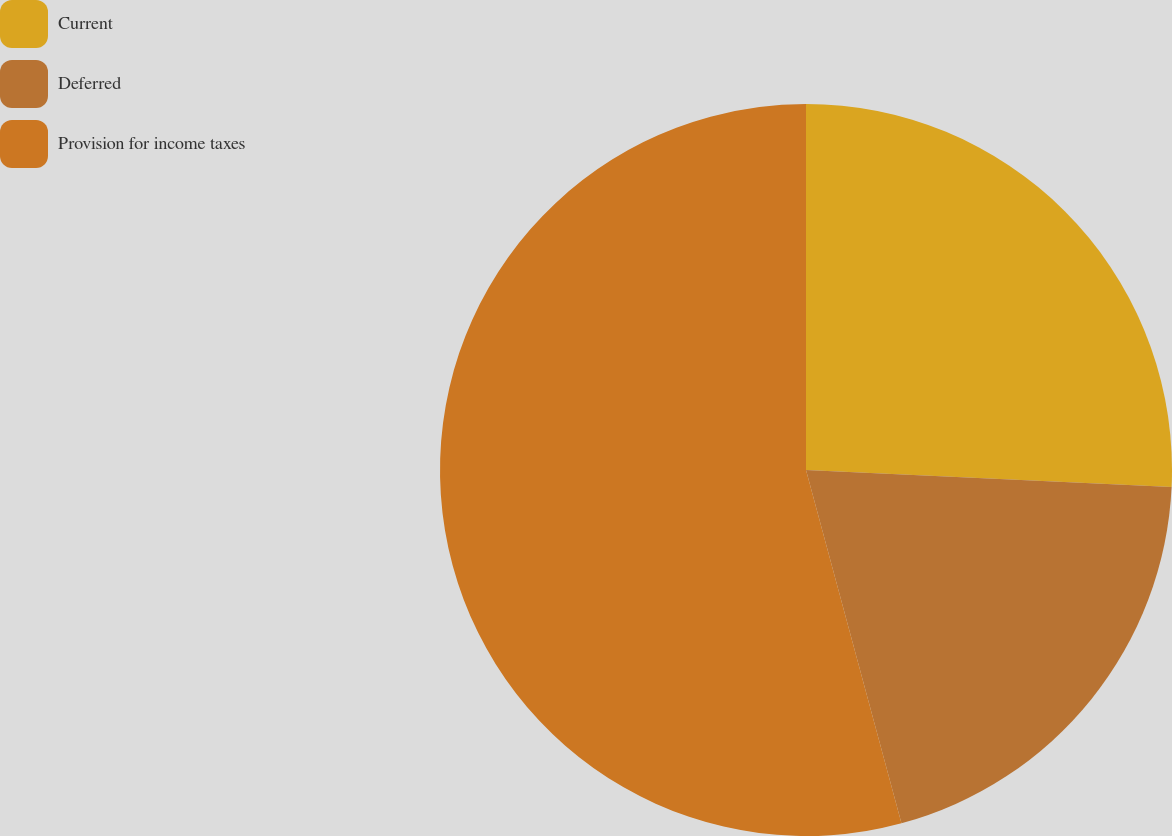<chart> <loc_0><loc_0><loc_500><loc_500><pie_chart><fcel>Current<fcel>Deferred<fcel>Provision for income taxes<nl><fcel>25.74%<fcel>20.06%<fcel>54.2%<nl></chart> 